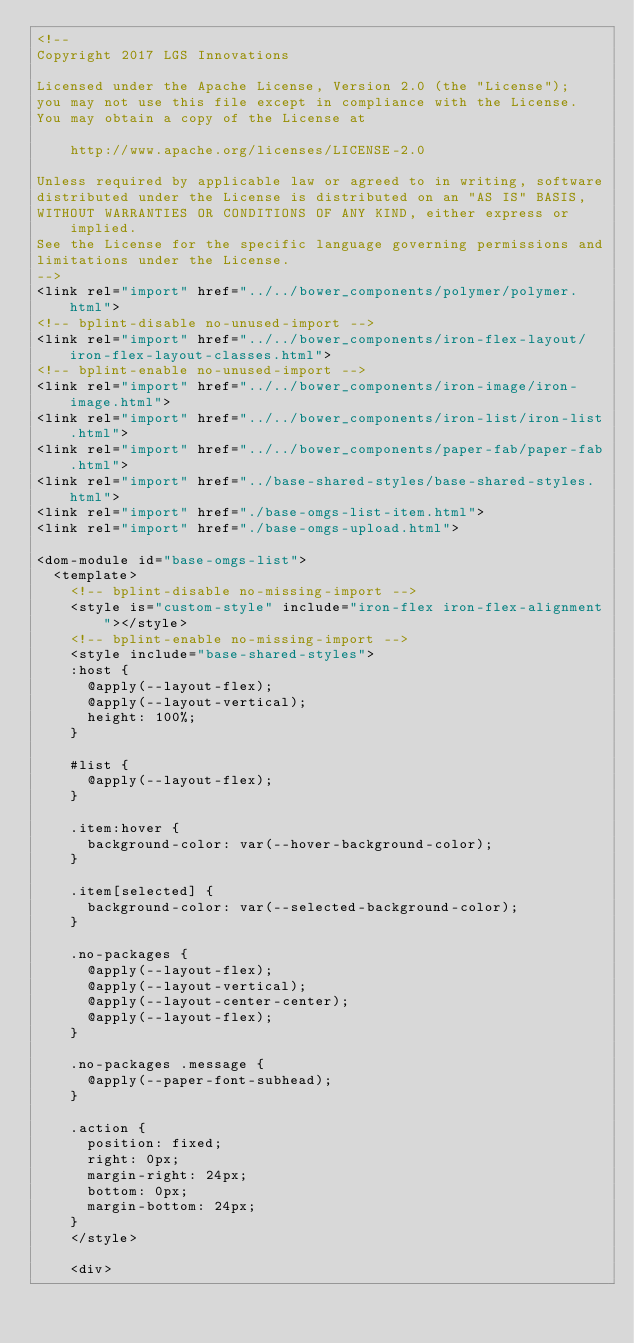<code> <loc_0><loc_0><loc_500><loc_500><_HTML_><!--
Copyright 2017 LGS Innovations

Licensed under the Apache License, Version 2.0 (the "License");
you may not use this file except in compliance with the License.
You may obtain a copy of the License at

    http://www.apache.org/licenses/LICENSE-2.0

Unless required by applicable law or agreed to in writing, software
distributed under the License is distributed on an "AS IS" BASIS,
WITHOUT WARRANTIES OR CONDITIONS OF ANY KIND, either express or implied.
See the License for the specific language governing permissions and
limitations under the License.
-->
<link rel="import" href="../../bower_components/polymer/polymer.html">
<!-- bplint-disable no-unused-import -->
<link rel="import" href="../../bower_components/iron-flex-layout/iron-flex-layout-classes.html">
<!-- bplint-enable no-unused-import -->
<link rel="import" href="../../bower_components/iron-image/iron-image.html">
<link rel="import" href="../../bower_components/iron-list/iron-list.html">
<link rel="import" href="../../bower_components/paper-fab/paper-fab.html">
<link rel="import" href="../base-shared-styles/base-shared-styles.html">
<link rel="import" href="./base-omgs-list-item.html">
<link rel="import" href="./base-omgs-upload.html">

<dom-module id="base-omgs-list">
  <template>
    <!-- bplint-disable no-missing-import -->
    <style is="custom-style" include="iron-flex iron-flex-alignment"></style>
    <!-- bplint-enable no-missing-import -->
    <style include="base-shared-styles">
    :host {
      @apply(--layout-flex);
      @apply(--layout-vertical);
      height: 100%;
    }

    #list {
      @apply(--layout-flex);
    }

    .item:hover {
      background-color: var(--hover-background-color);
    }

    .item[selected] {
      background-color: var(--selected-background-color);
    }

    .no-packages {
      @apply(--layout-flex);
      @apply(--layout-vertical);
      @apply(--layout-center-center);
      @apply(--layout-flex);
    }

    .no-packages .message {
      @apply(--paper-font-subhead);
    }

    .action {
      position: fixed;
      right: 0px;
      margin-right: 24px;
      bottom: 0px;
      margin-bottom: 24px;
    }
    </style>

    <div></code> 